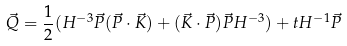<formula> <loc_0><loc_0><loc_500><loc_500>\vec { Q } = \frac { 1 } { 2 } ( H ^ { - 3 } \vec { P } ( \vec { P } \cdot \vec { K } ) + ( \vec { K } \cdot \vec { P } ) \vec { P } H ^ { - 3 } ) + t H ^ { - 1 } \vec { P }</formula> 